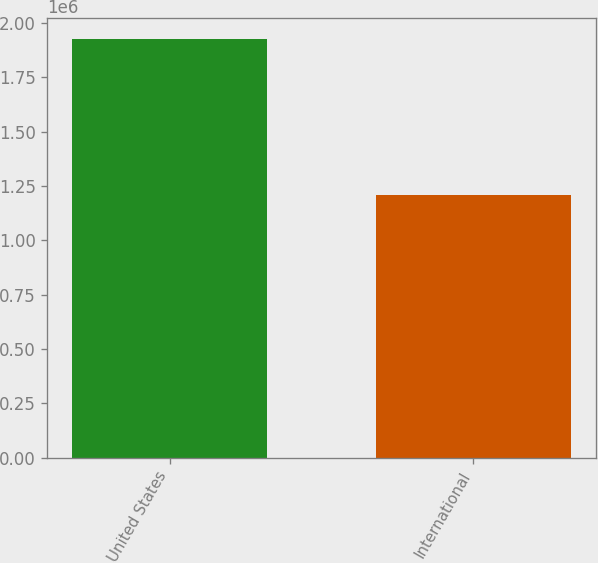Convert chart to OTSL. <chart><loc_0><loc_0><loc_500><loc_500><bar_chart><fcel>United States<fcel>International<nl><fcel>1.9276e+06<fcel>1.21106e+06<nl></chart> 